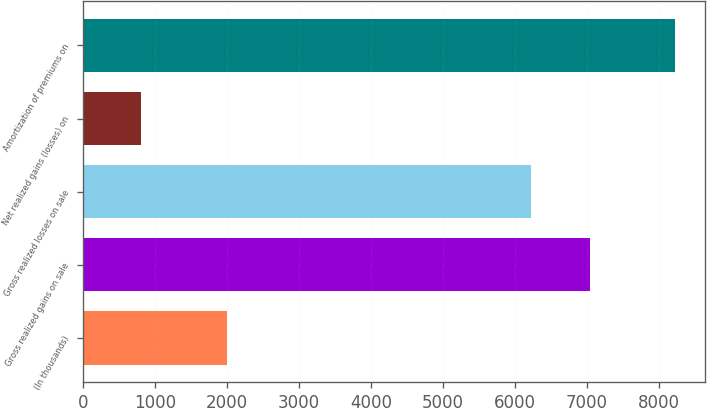Convert chart. <chart><loc_0><loc_0><loc_500><loc_500><bar_chart><fcel>(In thousands)<fcel>Gross realized gains on sale<fcel>Gross realized losses on sale<fcel>Net realized gains (losses) on<fcel>Amortization of premiums on<nl><fcel>2007<fcel>7041<fcel>6227<fcel>814<fcel>8229<nl></chart> 